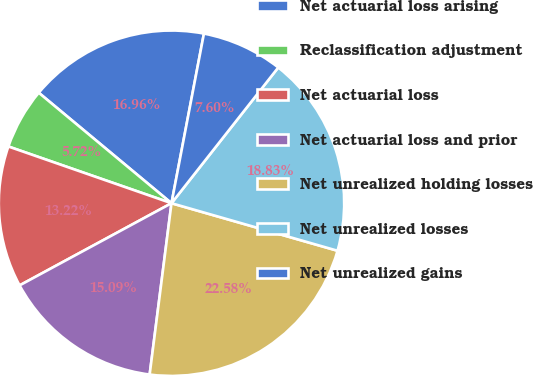<chart> <loc_0><loc_0><loc_500><loc_500><pie_chart><fcel>Net actuarial loss arising<fcel>Reclassification adjustment<fcel>Net actuarial loss<fcel>Net actuarial loss and prior<fcel>Net unrealized holding losses<fcel>Net unrealized losses<fcel>Net unrealized gains<nl><fcel>16.96%<fcel>5.72%<fcel>13.22%<fcel>15.09%<fcel>22.58%<fcel>18.83%<fcel>7.6%<nl></chart> 